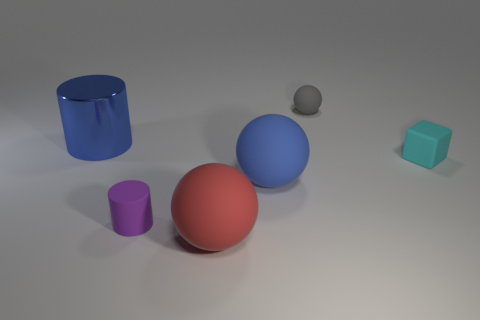What number of tiny objects are either green matte cubes or blue metallic cylinders?
Offer a terse response. 0. Is there a blue matte cylinder that has the same size as the cube?
Ensure brevity in your answer.  No. The tiny rubber object to the right of the gray ball to the right of the large matte object that is behind the tiny purple rubber object is what color?
Your answer should be compact. Cyan. Is the material of the tiny purple object the same as the tiny thing that is on the right side of the gray rubber object?
Your answer should be compact. Yes. What is the size of the gray object that is the same shape as the large red thing?
Offer a terse response. Small. Is the number of large blue rubber balls behind the big metal cylinder the same as the number of small purple matte cylinders that are in front of the big blue sphere?
Keep it short and to the point. No. What number of other things are there of the same material as the large blue ball
Your answer should be compact. 4. Are there an equal number of purple matte objects in front of the small matte cube and big rubber things?
Provide a short and direct response. No. There is a cyan rubber block; is it the same size as the blue object that is in front of the metallic cylinder?
Your response must be concise. No. There is a small object that is to the left of the small gray rubber thing; what is its shape?
Provide a short and direct response. Cylinder. 